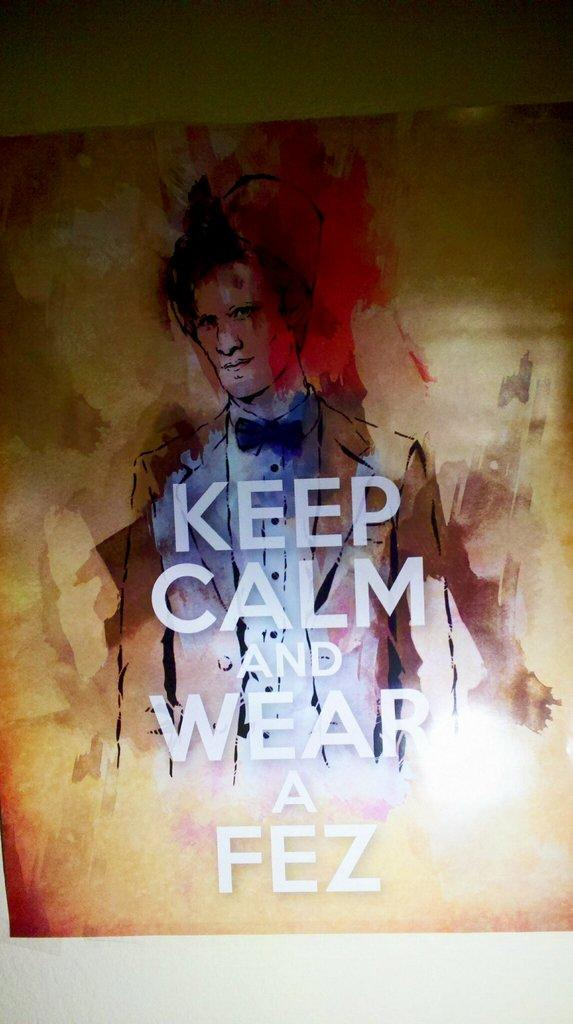What is the main subject of the image? The main subject of the image is a person's sketch. Is there any text or writing on the sketch? Yes, something is written on the sketch. What colors are present on the board in the image? The board has red, cream, and brown colors. How does the fog affect the curve in the image? There is no fog present in the image, and therefore no effect on any curves can be observed. 